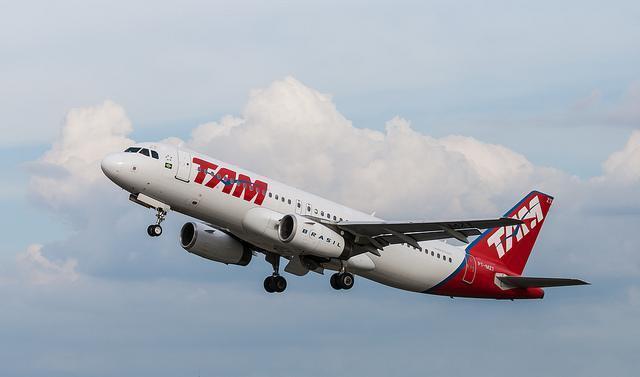How many engines does this plane have?
Give a very brief answer. 2. How many black horse are there in the image ?
Give a very brief answer. 0. 